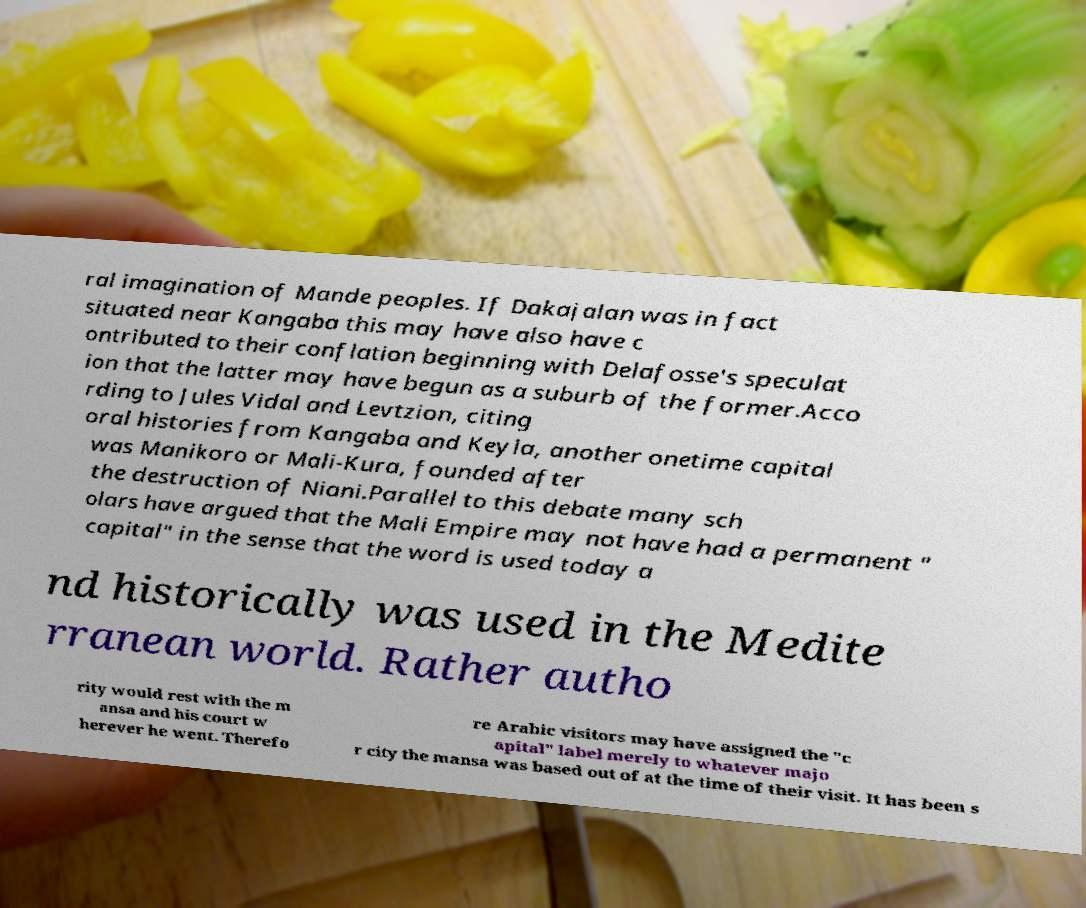Can you accurately transcribe the text from the provided image for me? ral imagination of Mande peoples. If Dakajalan was in fact situated near Kangaba this may have also have c ontributed to their conflation beginning with Delafosse's speculat ion that the latter may have begun as a suburb of the former.Acco rding to Jules Vidal and Levtzion, citing oral histories from Kangaba and Keyla, another onetime capital was Manikoro or Mali-Kura, founded after the destruction of Niani.Parallel to this debate many sch olars have argued that the Mali Empire may not have had a permanent " capital" in the sense that the word is used today a nd historically was used in the Medite rranean world. Rather autho rity would rest with the m ansa and his court w herever he went. Therefo re Arabic visitors may have assigned the "c apital" label merely to whatever majo r city the mansa was based out of at the time of their visit. It has been s 